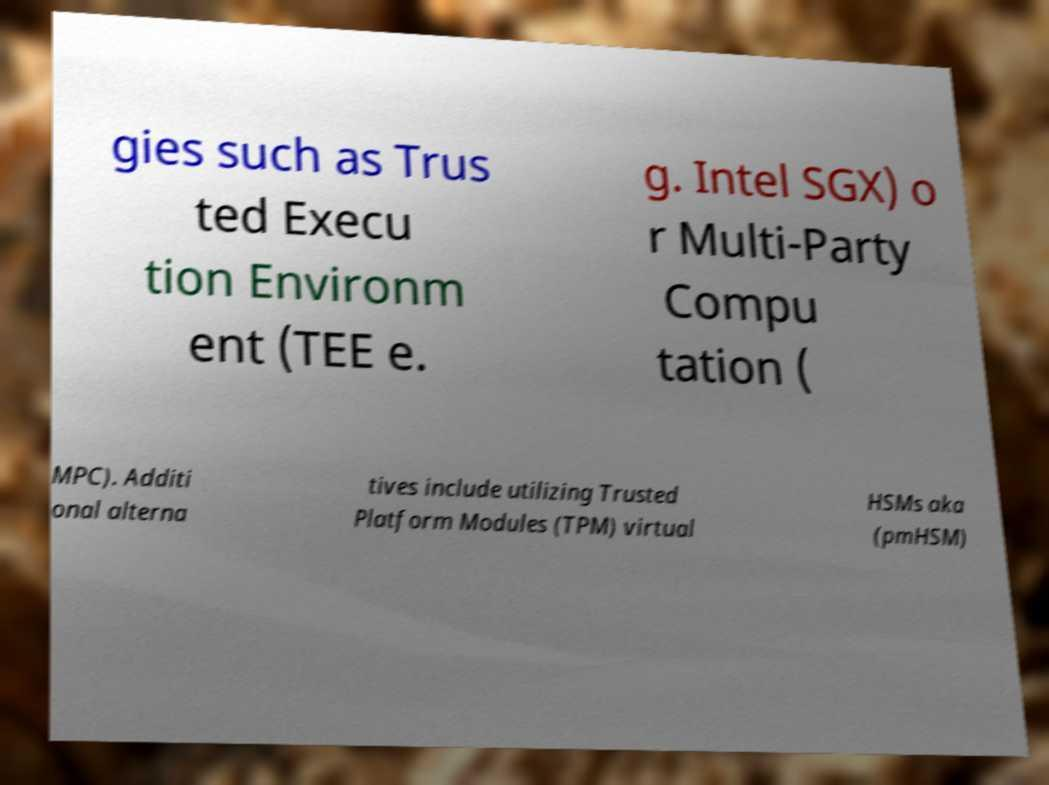Can you accurately transcribe the text from the provided image for me? gies such as Trus ted Execu tion Environm ent (TEE e. g. Intel SGX) o r Multi-Party Compu tation ( MPC). Additi onal alterna tives include utilizing Trusted Platform Modules (TPM) virtual HSMs aka (pmHSM) 